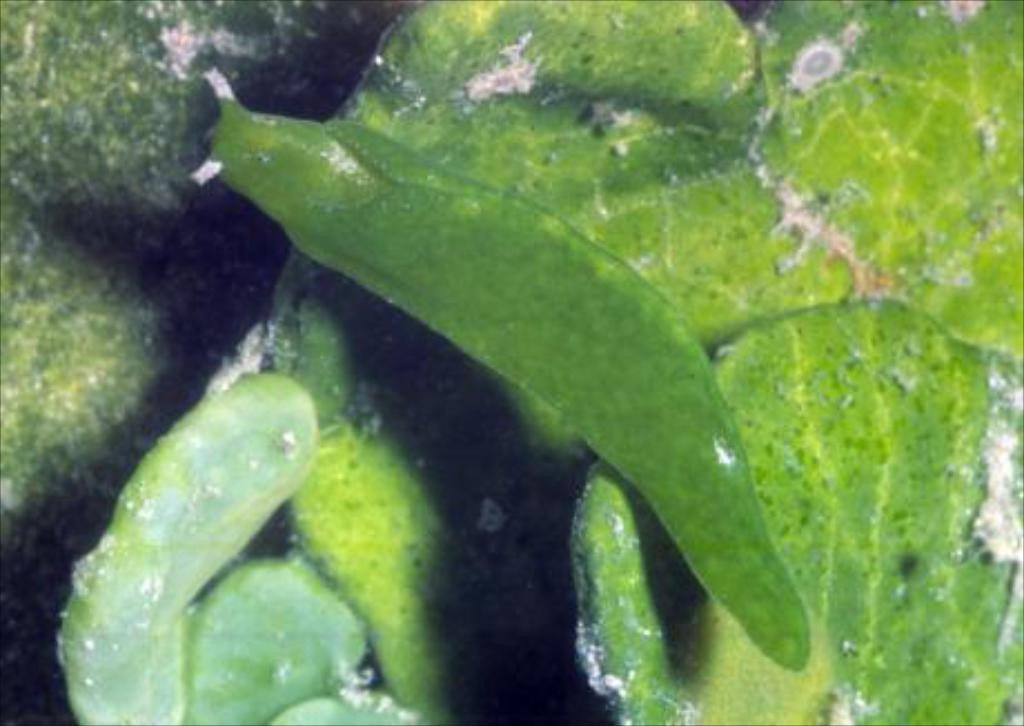What type of vegetation can be seen in the image? There are green leaves in the image. Is there any wildlife present in the image? Yes, there is a green color insect on the leaves. What nation is responsible for starting the process of creating the leaves in the image? The image does not provide information about the nation responsible for the leaves or the insect, nor does it suggest any process of creating them. 